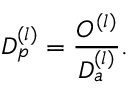<formula> <loc_0><loc_0><loc_500><loc_500>D _ { p } ^ { ( l ) } = { \frac { O ^ { ( l ) } } { D _ { a } ^ { ( l ) } } } .</formula> 